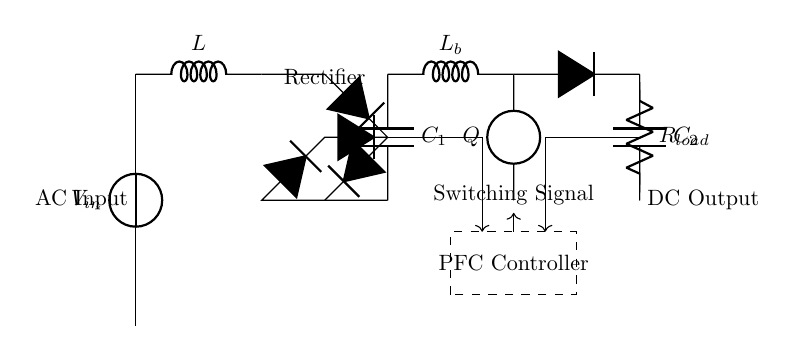What is the type of voltage source used in the circuit? The circuit uses a direct current voltage source, as indicated by the "vsource" label that denotes it.
Answer: Direct current What component is used to smooth out the input voltage? The component used to smooth the input voltage is a capacitor labeled "C1," positioned after the bridge rectifier in the circuit, which is typically used for filtering.
Answer: C1 What is the function of the inductor labeled "L"? The inductor "L" serves as a line filter, helping to reduce voltage spikes and providing inductive reactance to control current flow in the circuit.
Answer: Line filter What role does the PFC controller play in this circuit? The PFC controller manages the power factor correction in this circuit, optimizing the input power and thus improving efficiency by controlling the switching signals to the boost converter.
Answer: Power factor correction What type of load is presented in the circuit? The load is represented by the resistor labeled "R load," which typically simulates a resistive load for testing the power supply characteristics of the circuit.
Answer: Resistive load How many capacitors are present in the circuit, and what are their labels? There are two capacitors in the circuit, labeled "C1" and "C2," which serve distinct purposes in smoothing and filtering the voltage at different stages of power conversion.
Answer: Two capacitors, C1 and C2 At what point in the circuit does the output voltage appear? The output voltage appears after the load "R load" and is shown at the point labeled "DC Output," which is the terminal where the DC voltage is delivered following the load.
Answer: DC Output 